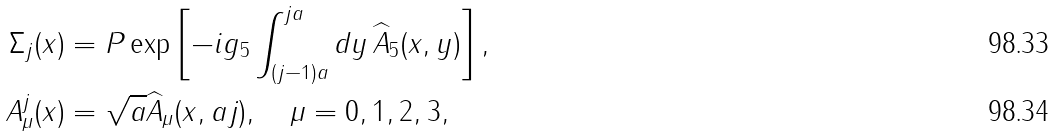Convert formula to latex. <formula><loc_0><loc_0><loc_500><loc_500>\Sigma _ { j } ( x ) & = P \exp \left [ - i g _ { 5 } \int _ { ( j - 1 ) a } ^ { j a } d y \, \widehat { A } _ { 5 } ( x , y ) \right ] , \\ A ^ { j } _ { \mu } ( x ) & = \sqrt { a } \widehat { A } _ { \mu } ( x , a j ) , \quad \mu = 0 , 1 , 2 , 3 ,</formula> 